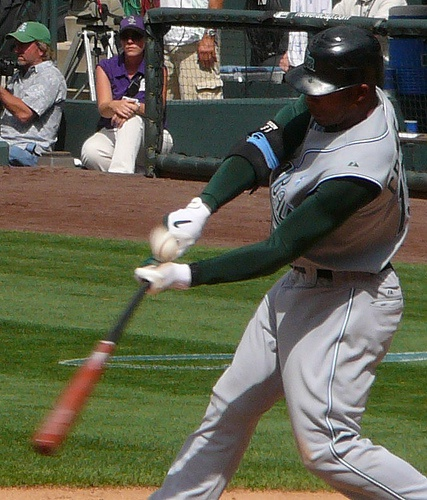Describe the objects in this image and their specific colors. I can see people in black, gray, darkgray, and lightgray tones, people in black, lightgray, gray, and purple tones, people in black, darkgray, gray, and lightgray tones, baseball bat in black, olive, brown, and darkgreen tones, and people in black, tan, and brown tones in this image. 